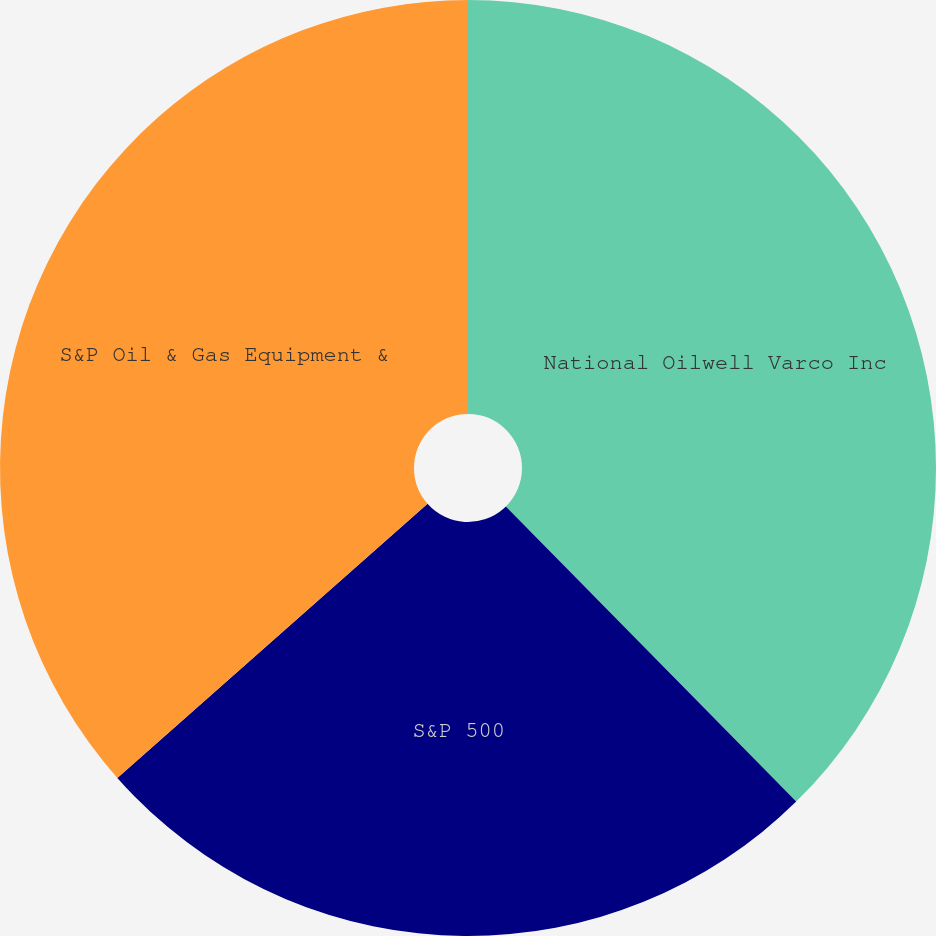Convert chart to OTSL. <chart><loc_0><loc_0><loc_500><loc_500><pie_chart><fcel>National Oilwell Varco Inc<fcel>S&P 500<fcel>S&P Oil & Gas Equipment &<nl><fcel>37.63%<fcel>25.85%<fcel>36.52%<nl></chart> 